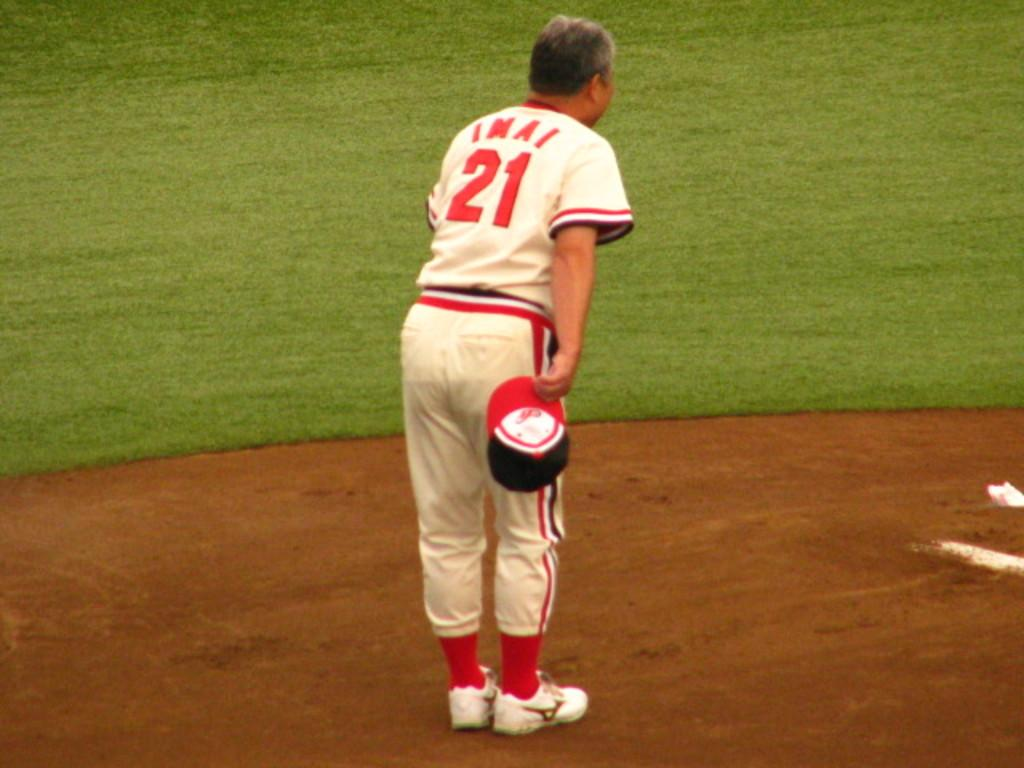<image>
Render a clear and concise summary of the photo. Baseball player number 21 is standing in the dirt on the baseball field with his hat off and bowing. 